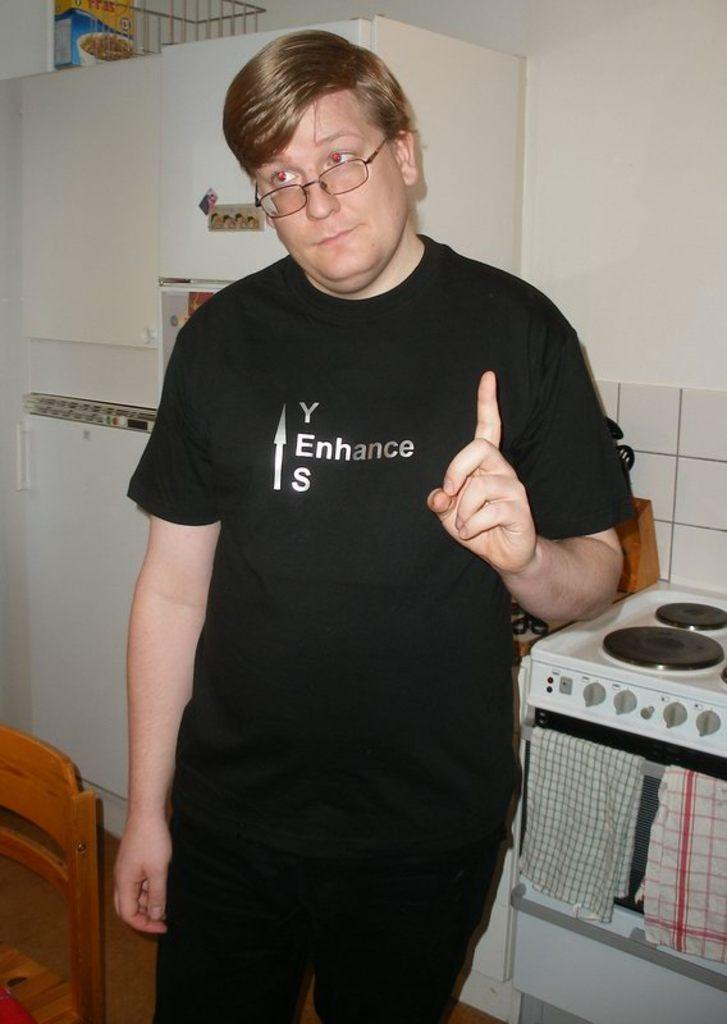<image>
Provide a brief description of the given image. A young man wears a black T shirt that says yes enhance. 